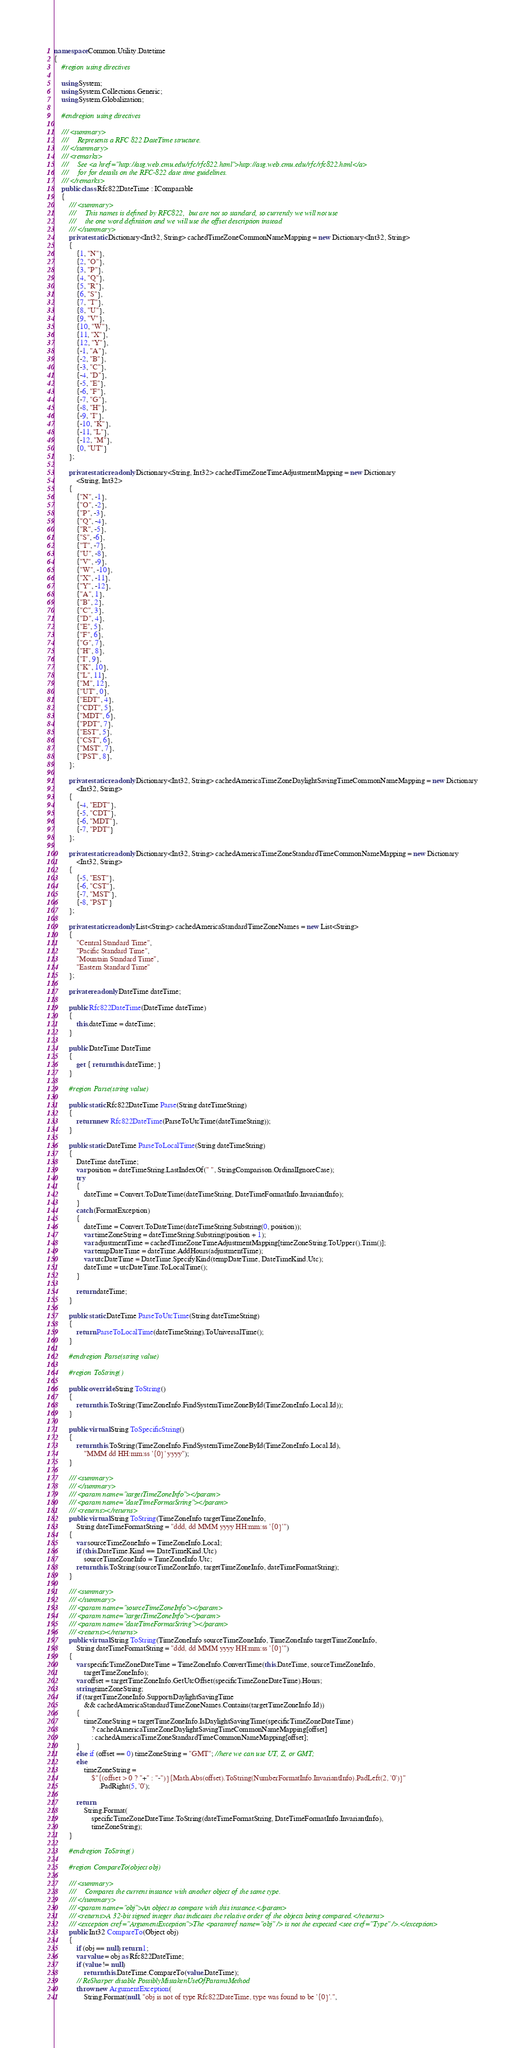Convert code to text. <code><loc_0><loc_0><loc_500><loc_500><_C#_>namespace Common.Utility.Datetime
{
    #region using directives

    using System;
    using System.Collections.Generic;
    using System.Globalization;

    #endregion using directives

    /// <summary>
    ///     Represents a RFC 822 DateTime structure.
    /// </summary>
    /// <remarks>
    ///     See <a href="http://asg.web.cmu.edu/rfc/rfc822.html">http://asg.web.cmu.edu/rfc/rfc822.html</a>
    ///     for for details on the RFC-822 date time guidelines.
    /// </remarks>
    public class Rfc822DateTime : IComparable
    {
        /// <summary>
        ///     This names is defined by RFC822,  but are not so standard, so currently we will not use
        ///     the one word definition and we will use the offset description instead
        /// </summary>
        private static Dictionary<Int32, String> cachedTimeZoneCommonNameMapping = new Dictionary<Int32, String>
        {
            {1, "N"},
            {2, "O"},
            {3, "P"},
            {4, "Q"},
            {5, "R"},
            {6, "S"},
            {7, "T"},
            {8, "U"},
            {9, "V"},
            {10, "W"},
            {11, "X"},
            {12, "Y"},
            {-1, "A"},
            {-2, "B"},
            {-3, "C"},
            {-4, "D"},
            {-5, "E"},
            {-6, "F"},
            {-7, "G"},
            {-8, "H"},
            {-9, "I"},
            {-10, "K"},
            {-11, "L"},
            {-12, "M"},
            {0, "UT"}
        };

        private static readonly Dictionary<String, Int32> cachedTimeZoneTimeAdjustmentMapping = new Dictionary
            <String, Int32>
        {
            {"N", -1},
            {"O", -2},
            {"P", -3},
            {"Q", -4},
            {"R", -5},
            {"S", -6},
            {"T", -7},
            {"U", -8},
            {"V", -9},
            {"W", -10},
            {"X", -11},
            {"Y", -12},
            {"A", 1},
            {"B", 2},
            {"C", 3},
            {"D", 4},
            {"E", 5},
            {"F", 6},
            {"G", 7},
            {"H", 8},
            {"I", 9},
            {"K", 10},
            {"L", 11},
            {"M", 12},
            {"UT", 0},
            {"EDT", 4},
            {"CDT", 5},
            {"MDT", 6},
            {"PDT", 7},
            {"EST", 5},
            {"CST", 6},
            {"MST", 7},
            {"PST", 8},
        };

        private static readonly Dictionary<Int32, String> cachedAmericaTimeZoneDaylightSavingTimeCommonNameMapping = new Dictionary
            <Int32, String>
        {
            {-4, "EDT"},
            {-5, "CDT"},
            {-6, "MDT"},
            {-7, "PDT"}
        };

        private static readonly Dictionary<Int32, String> cachedAmericaTimeZoneStandardTimeCommonNameMapping = new Dictionary
            <Int32, String>
        {
            {-5, "EST"},
            {-6, "CST"},
            {-7, "MST"},
            {-8, "PST"}
        };

        private static readonly List<String> cachedAmericaStandardTimeZoneNames = new List<String>
        {
            "Central Standard Time",
            "Pacific Standard Time",
            "Mountain Standard Time",
            "Eastern Standard Time"
        };

        private readonly DateTime dateTime;

        public Rfc822DateTime(DateTime dateTime)
        {
            this.dateTime = dateTime;
        }

        public DateTime DateTime
        {
            get { return this.dateTime; }
        }

        #region Parse(string value)

        public static Rfc822DateTime Parse(String dateTimeString)
        {
            return new Rfc822DateTime(ParseToUtcTime(dateTimeString));
        }

        public static DateTime ParseToLocalTime(String dateTimeString)
        {
            DateTime dateTime;
            var position = dateTimeString.LastIndexOf(" ", StringComparison.OrdinalIgnoreCase);
            try
            {
                dateTime = Convert.ToDateTime(dateTimeString, DateTimeFormatInfo.InvariantInfo);
            }
            catch (FormatException)
            {
                dateTime = Convert.ToDateTime(dateTimeString.Substring(0, position));
                var timeZoneString = dateTimeString.Substring(position + 1);
                var adjustmentTime = cachedTimeZoneTimeAdjustmentMapping[timeZoneString.ToUpper().Trim()];
                var tempDateTime = dateTime.AddHours(adjustmentTime);
                var utcDateTime = DateTime.SpecifyKind(tempDateTime, DateTimeKind.Utc);
                dateTime = utcDateTime.ToLocalTime();
            }

            return dateTime;
        }

        public static DateTime ParseToUtcTime(String dateTimeString)
        {
            return ParseToLocalTime(dateTimeString).ToUniversalTime();
        }

        #endregion Parse(string value)

        #region ToString()

        public override String ToString()
        {
            return this.ToString(TimeZoneInfo.FindSystemTimeZoneById(TimeZoneInfo.Local.Id));
        }

        public virtual String ToSpecificString()
        {
            return this.ToString(TimeZoneInfo.FindSystemTimeZoneById(TimeZoneInfo.Local.Id),
                "MMM dd HH:mm:ss '{0}' yyyy");
        }

        /// <summary>
        /// </summary>
        /// <param name="targetTimeZoneInfo"></param>
        /// <param name="dateTimeFormatString"></param>
        /// <returns></returns>
        public virtual String ToString(TimeZoneInfo targetTimeZoneInfo,
            String dateTimeFormatString = "ddd, dd MMM yyyy HH:mm:ss '{0}'")
        {
            var sourceTimeZoneInfo = TimeZoneInfo.Local;
            if (this.DateTime.Kind == DateTimeKind.Utc)
                sourceTimeZoneInfo = TimeZoneInfo.Utc;
            return this.ToString(sourceTimeZoneInfo, targetTimeZoneInfo, dateTimeFormatString);
        }

        /// <summary>
        /// </summary>
        /// <param name="sourceTimeZoneInfo"></param>
        /// <param name="targetTimeZoneInfo"></param>
        /// <param name="dateTimeFormatString"></param>
        /// <returns></returns>
        public virtual String ToString(TimeZoneInfo sourceTimeZoneInfo, TimeZoneInfo targetTimeZoneInfo,
            String dateTimeFormatString = "ddd, dd MMM yyyy HH:mm:ss '{0}'")
        {
            var specificTimeZoneDateTime = TimeZoneInfo.ConvertTime(this.DateTime, sourceTimeZoneInfo,
                targetTimeZoneInfo);
            var offset = targetTimeZoneInfo.GetUtcOffset(specificTimeZoneDateTime).Hours;
            string timeZoneString;
            if (targetTimeZoneInfo.SupportsDaylightSavingTime
                && cachedAmericaStandardTimeZoneNames.Contains(targetTimeZoneInfo.Id))
            {
                timeZoneString = targetTimeZoneInfo.IsDaylightSavingTime(specificTimeZoneDateTime)
                    ? cachedAmericaTimeZoneDaylightSavingTimeCommonNameMapping[offset]
                    : cachedAmericaTimeZoneStandardTimeCommonNameMapping[offset];
            }
            else if (offset == 0) timeZoneString = "GMT"; //here we can use UT, Z, or GMT;
            else
                timeZoneString =
                    $"{(offset > 0 ? "+" : "-")}{Math.Abs(offset).ToString(NumberFormatInfo.InvariantInfo).PadLeft(2, '0')}"
                        .PadRight(5, '0');

            return
                String.Format(
                    specificTimeZoneDateTime.ToString(dateTimeFormatString, DateTimeFormatInfo.InvariantInfo),
                    timeZoneString);
        }

        #endregion ToString()

        #region CompareTo(object obj)

        /// <summary>
        ///     Compares the current instance with another object of the same type.
        /// </summary>
        /// <param name="obj">An object to compare with this instance.</param>
        /// <returns>A 32-bit signed integer that indicates the relative order of the objects being compared.</returns>
        /// <exception cref="ArgumentException">The <paramref name="obj" /> is not the expected <see cref="Type" />.</exception>
        public Int32 CompareTo(Object obj)
        {
            if (obj == null) return 1;
            var value = obj as Rfc822DateTime;
            if (value != null)
                return this.DateTime.CompareTo(value.DateTime);
            // ReSharper disable PossiblyMistakenUseOfParamsMethod
            throw new ArgumentException(
                String.Format(null, "obj is not of type Rfc822DateTime, type was found to be '{0}'.",</code> 